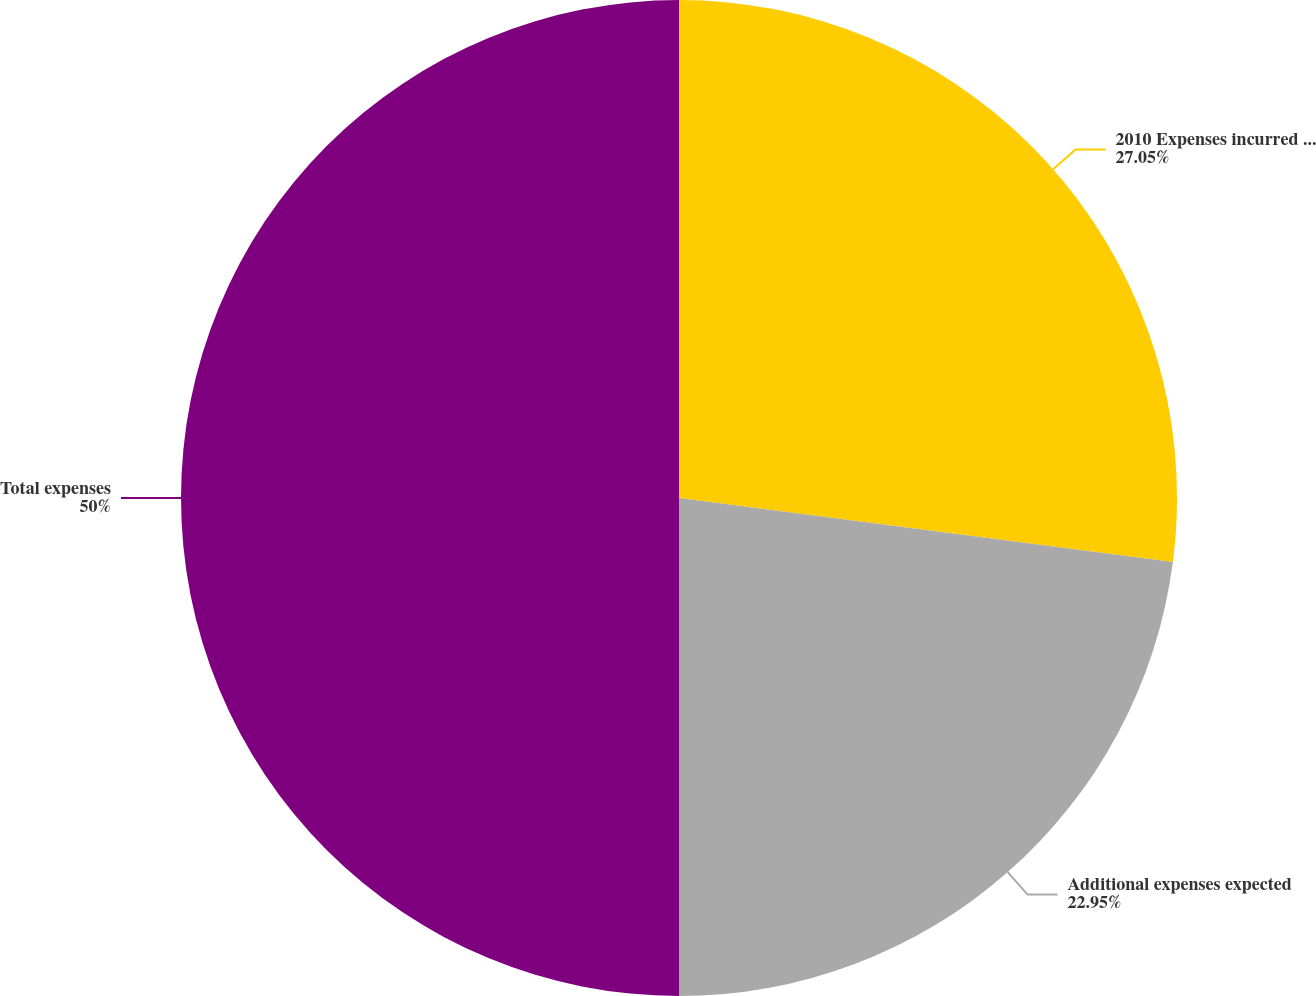Convert chart to OTSL. <chart><loc_0><loc_0><loc_500><loc_500><pie_chart><fcel>2010 Expenses incurred to date<fcel>Additional expenses expected<fcel>Total expenses<nl><fcel>27.05%<fcel>22.95%<fcel>50.0%<nl></chart> 